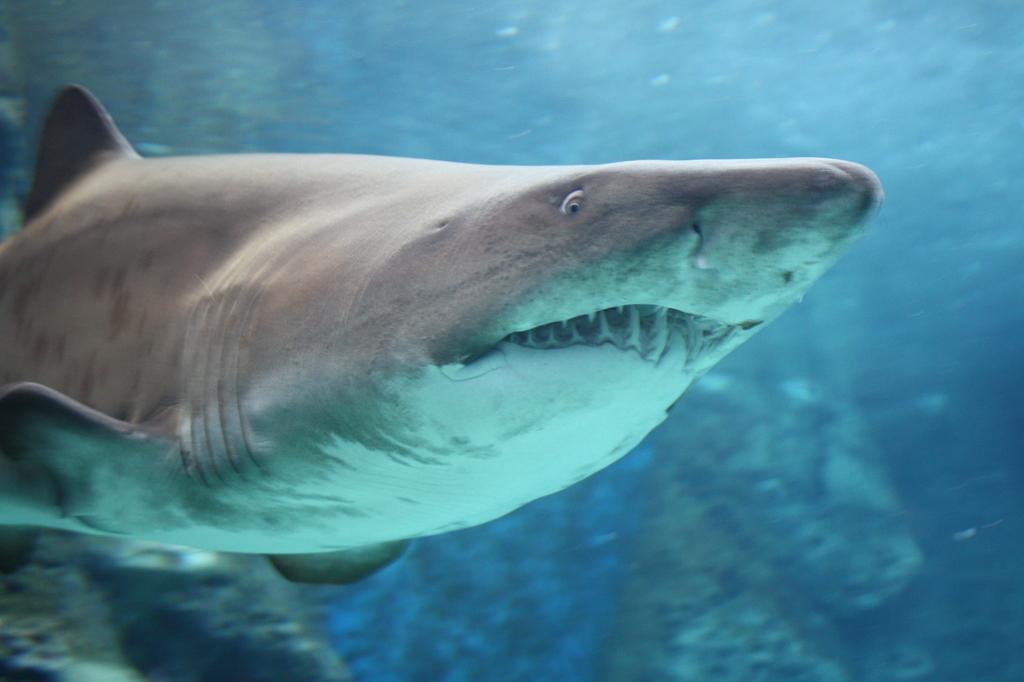Can you describe this image briefly? In this image I can see sharks in the water. In the background I can see rocks. 